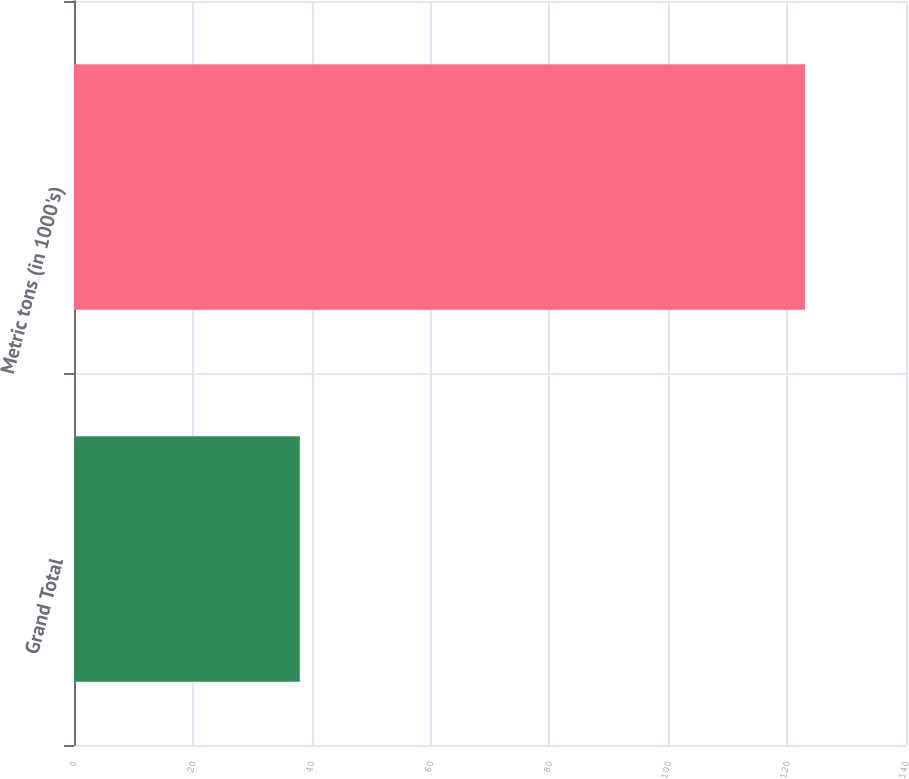<chart> <loc_0><loc_0><loc_500><loc_500><bar_chart><fcel>Grand Total<fcel>Metric tons (in 1000's)<nl><fcel>38<fcel>123<nl></chart> 